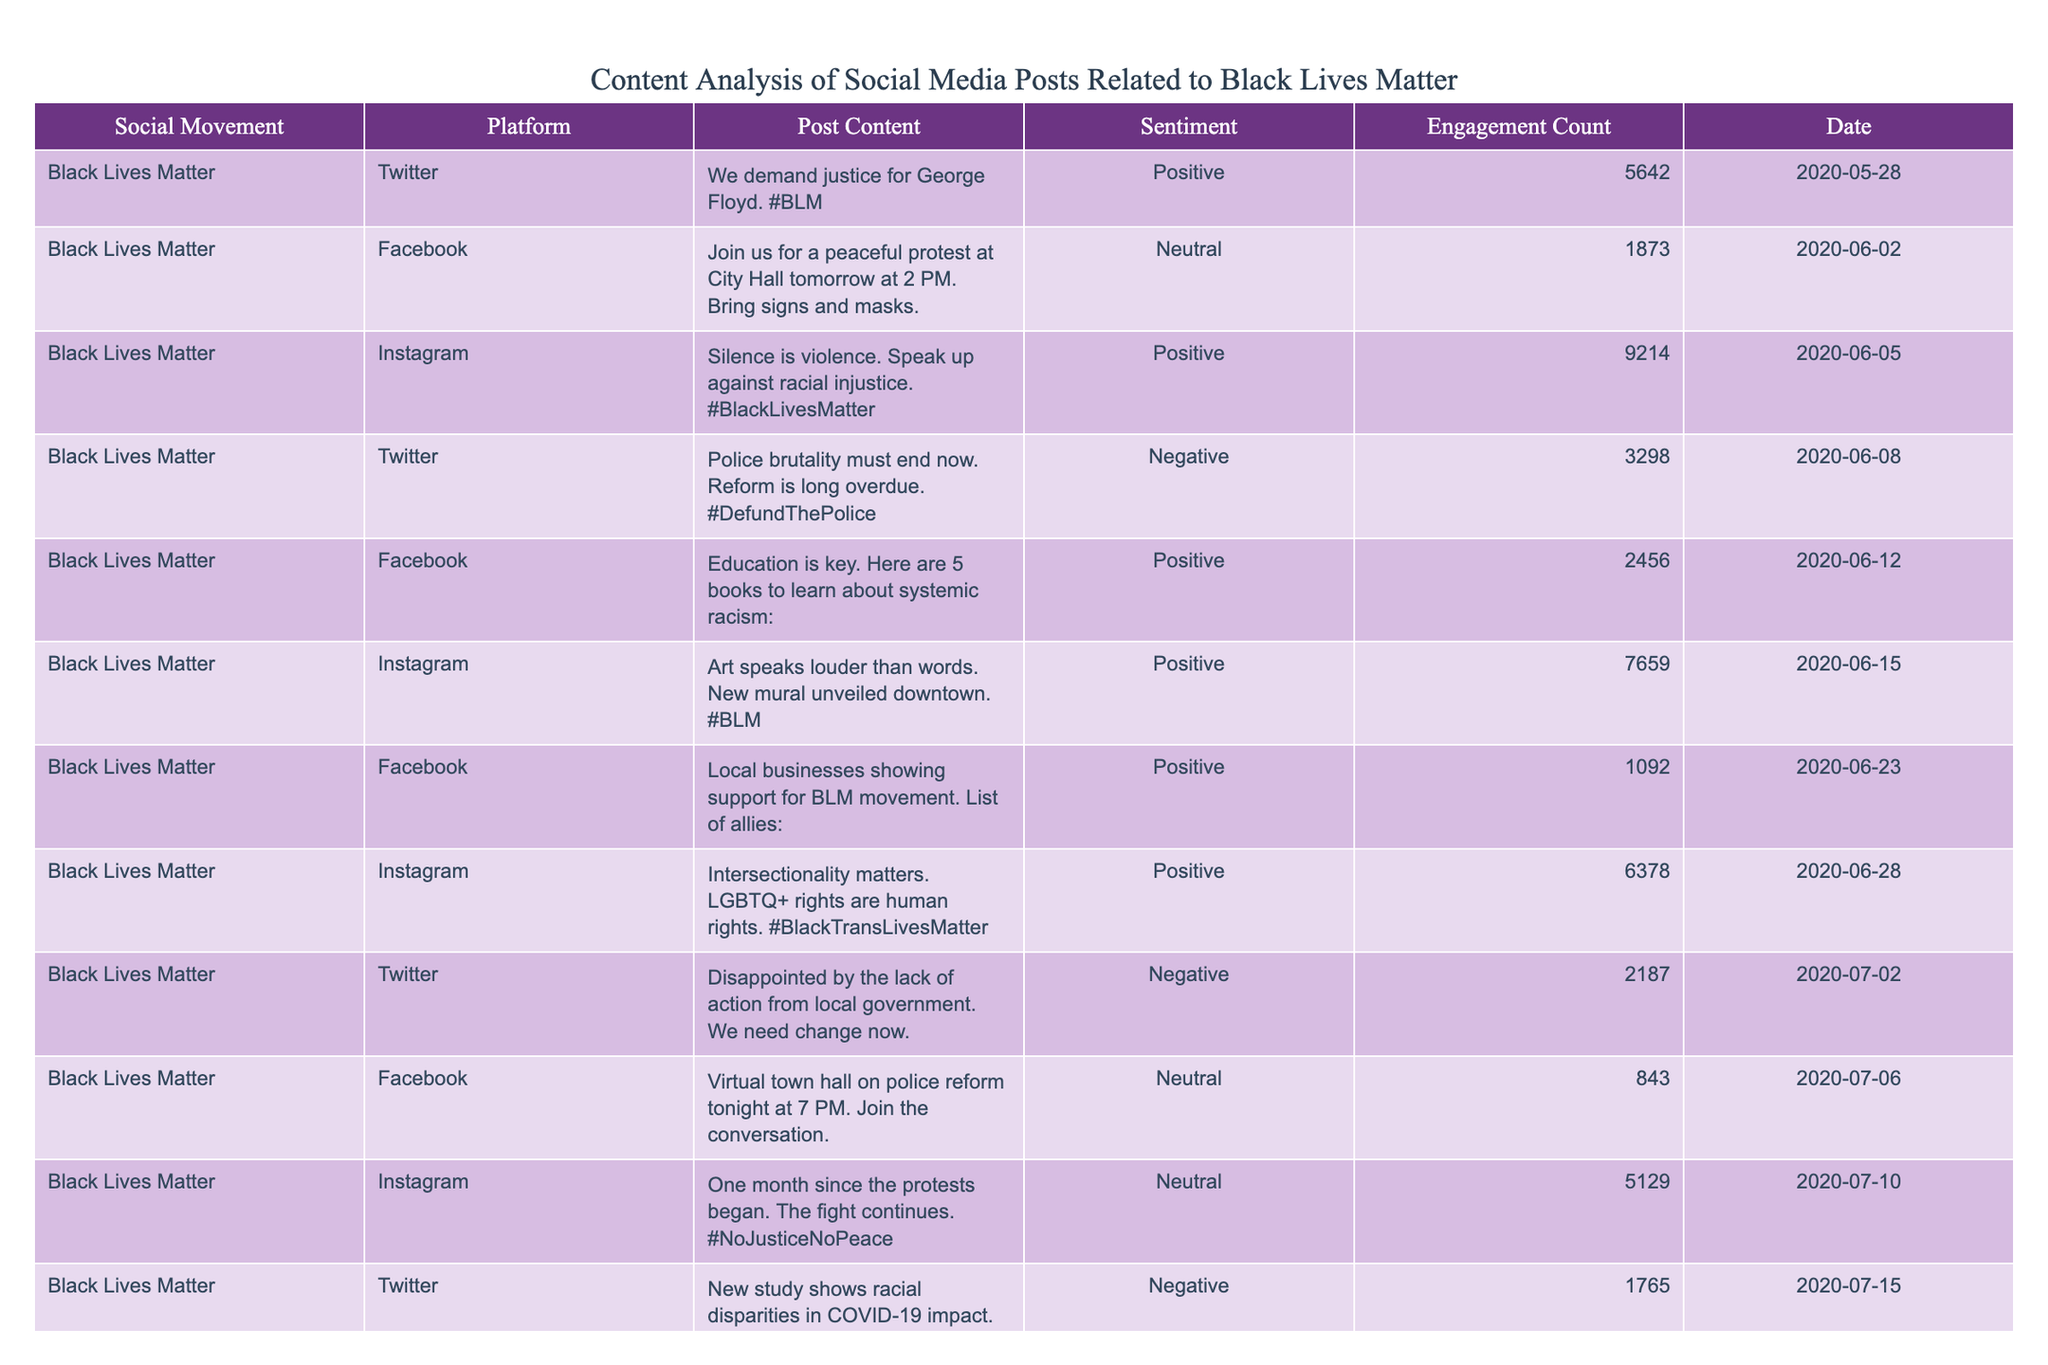What is the total engagement count for all Instagram posts? The engagement counts for Instagram posts are 9214, 7659, 6378, 5129, and 4287. Summing these values gives 9214 + 7659 + 6378 + 5129 + 4287 = 32667.
Answer: 32667 How many posts were made on Twitter? The table has 4 entries for Twitter: the posts on May 28, June 8, July 2, and July 15. Therefore, there are 4 Twitter posts.
Answer: 4 What sentiment is associated with the post about police brutality from Twitter? The post from Twitter on June 8 states, "Police brutality must end now" and is marked as Negative.
Answer: Negative Which platform had the highest engagement count for a single post? Reviewing all the engagement counts, the highest individual count is from Instagram on June 5, which is 9214.
Answer: Instagram What is the average engagement count for Facebook posts? The engagement counts for Facebook posts are 1873, 2456, 1092, 843, and 976. The total is 1873 + 2456 + 1092 + 843 + 976 = 6198. There are 5 Facebook posts, so the average is 6198 / 5 = 1239.6.
Answer: 1239.6 Are there any posts with neutral sentiment? The table contains three entries with neutral sentiment: one from Facebook on June 2, one from Facebook on July 6, and the Instagram post on July 10. Therefore, yes, there are neutral sentiment posts.
Answer: Yes On what date was the post urging support for Black-owned businesses made on Instagram? The post urging support for Black-owned businesses on Instagram was made on July 23.
Answer: July 23 What is the difference between the highest and lowest engagement counts for Twitter posts? The engagement counts for Twitter posts are 5642, 3298, 2187, and 1765. The highest is 5642 and the lowest is 1765. Therefore, the difference is 5642 - 1765 = 3877.
Answer: 3877 Which social movement's posts are analyzed in this table? The table specifically analyzes posts related to the Black Lives Matter social movement.
Answer: Black Lives Matter How many posts included the hashtag #BLM? The posts that include the hashtag #BLM are: the one on May 28 and the one on June 5, making a total of 2 posts with the hashtag.
Answer: 2 